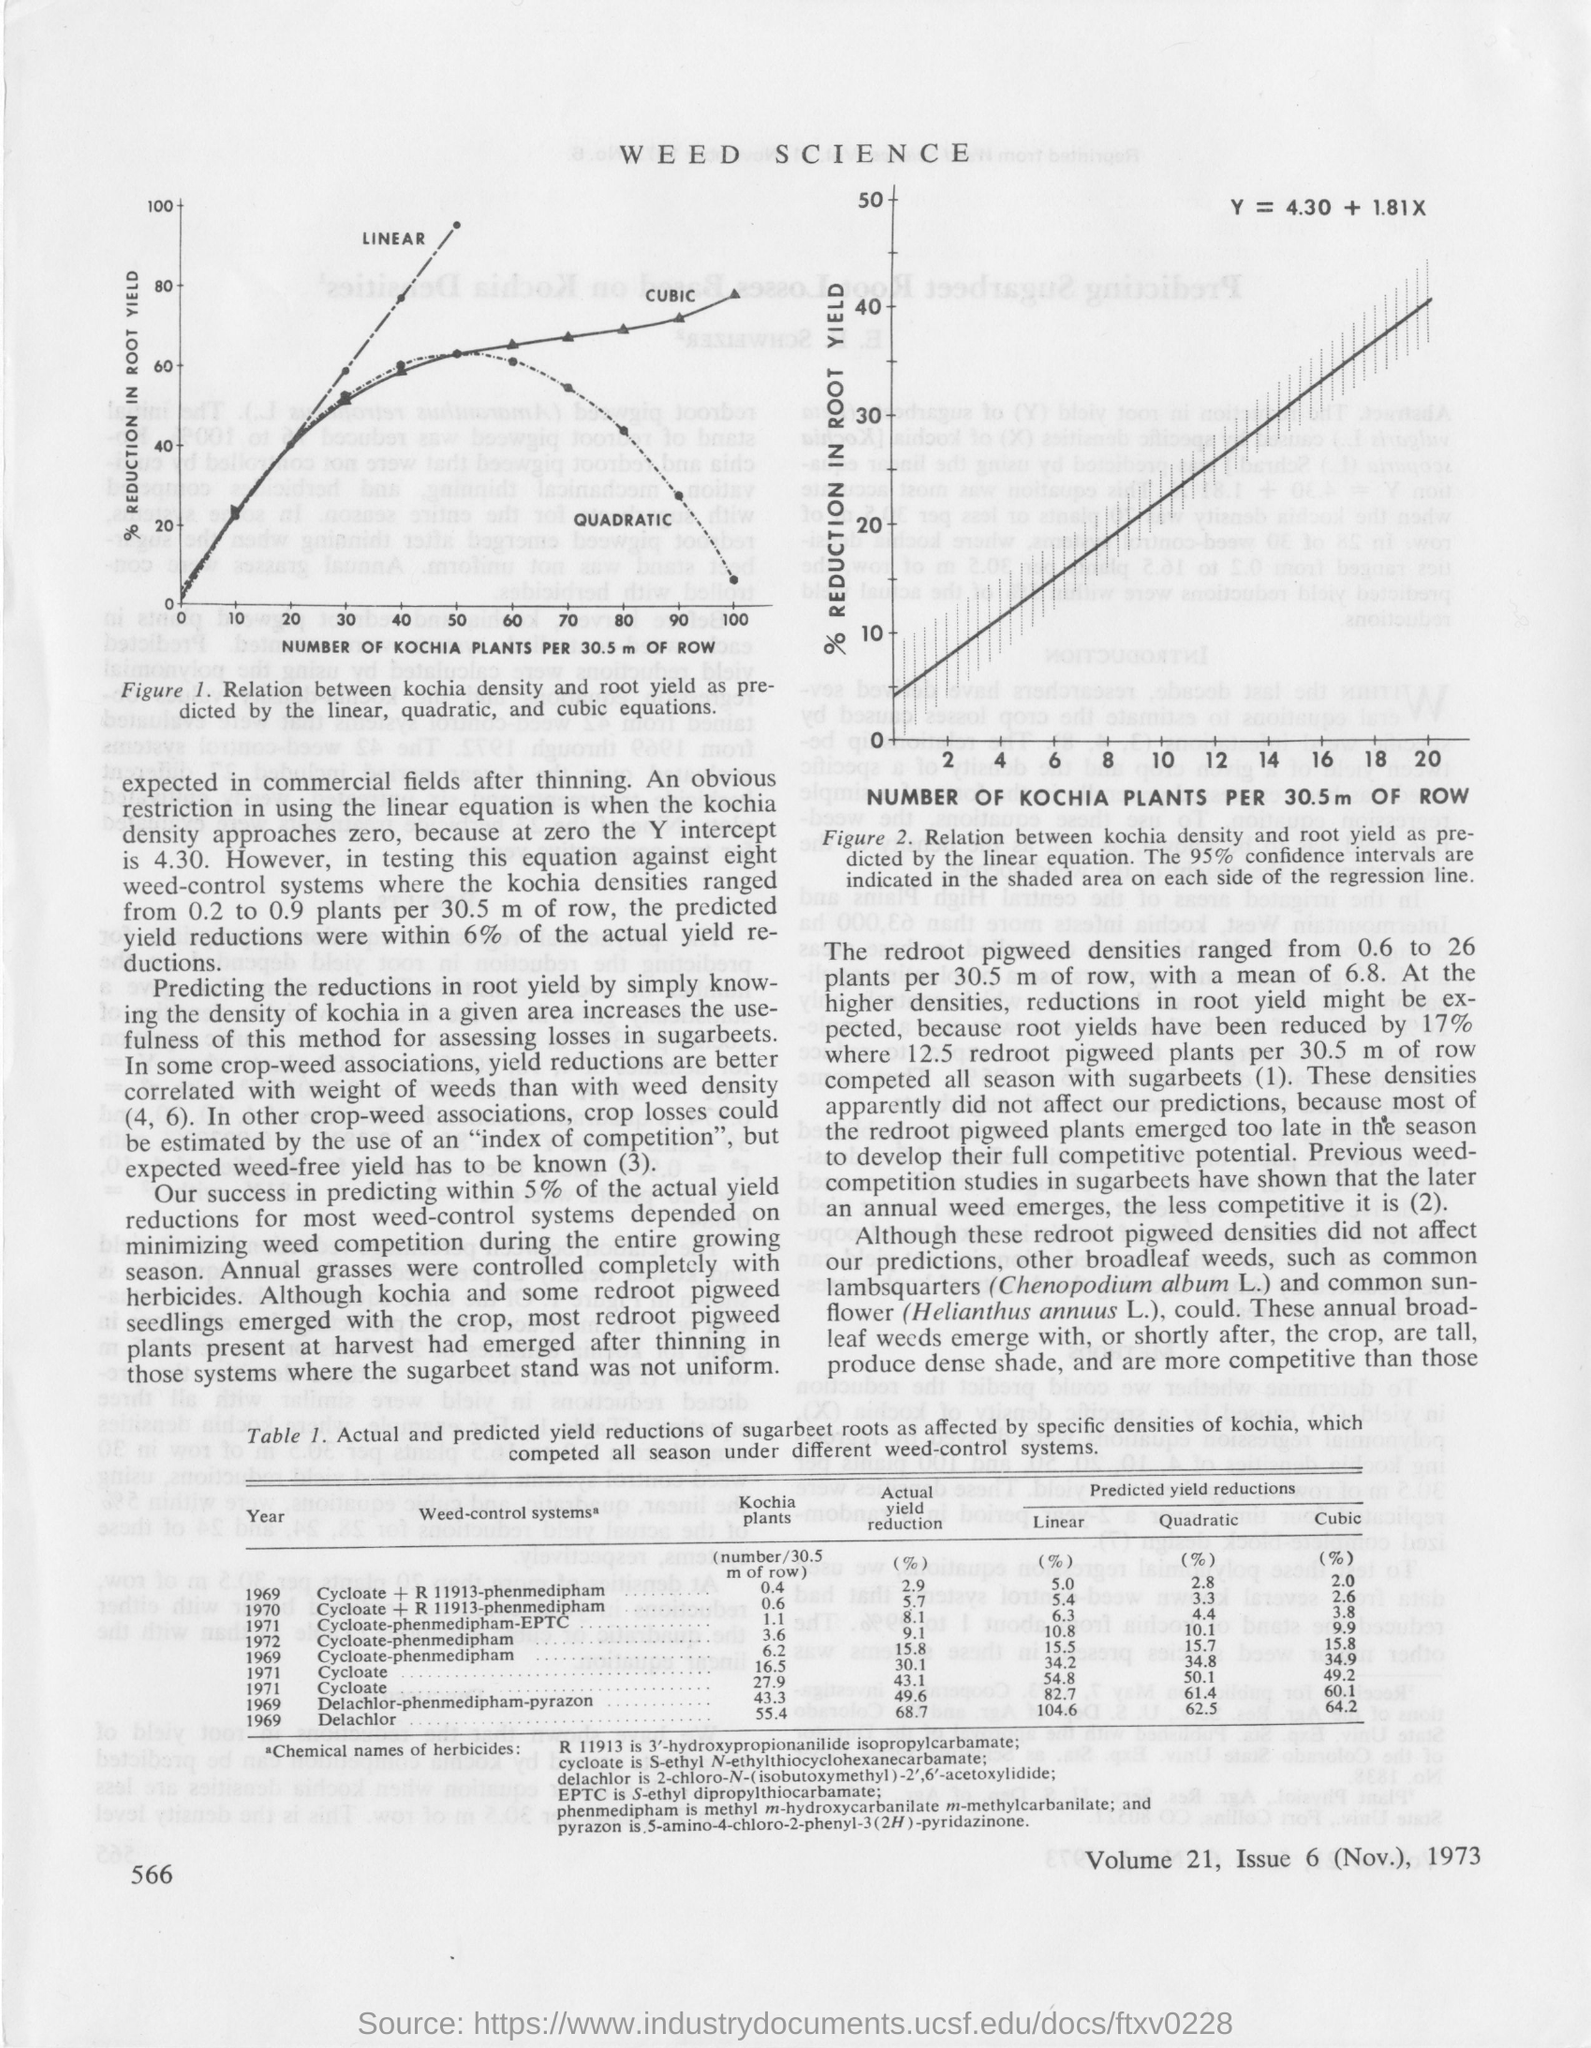Specify some key components in this picture. The document's first title is 'WEED SCIENCE.' The formula to calculate Y is Y = 4.30 + 1.81X, where Y represents the dependent variable and X represents the independent variable. 